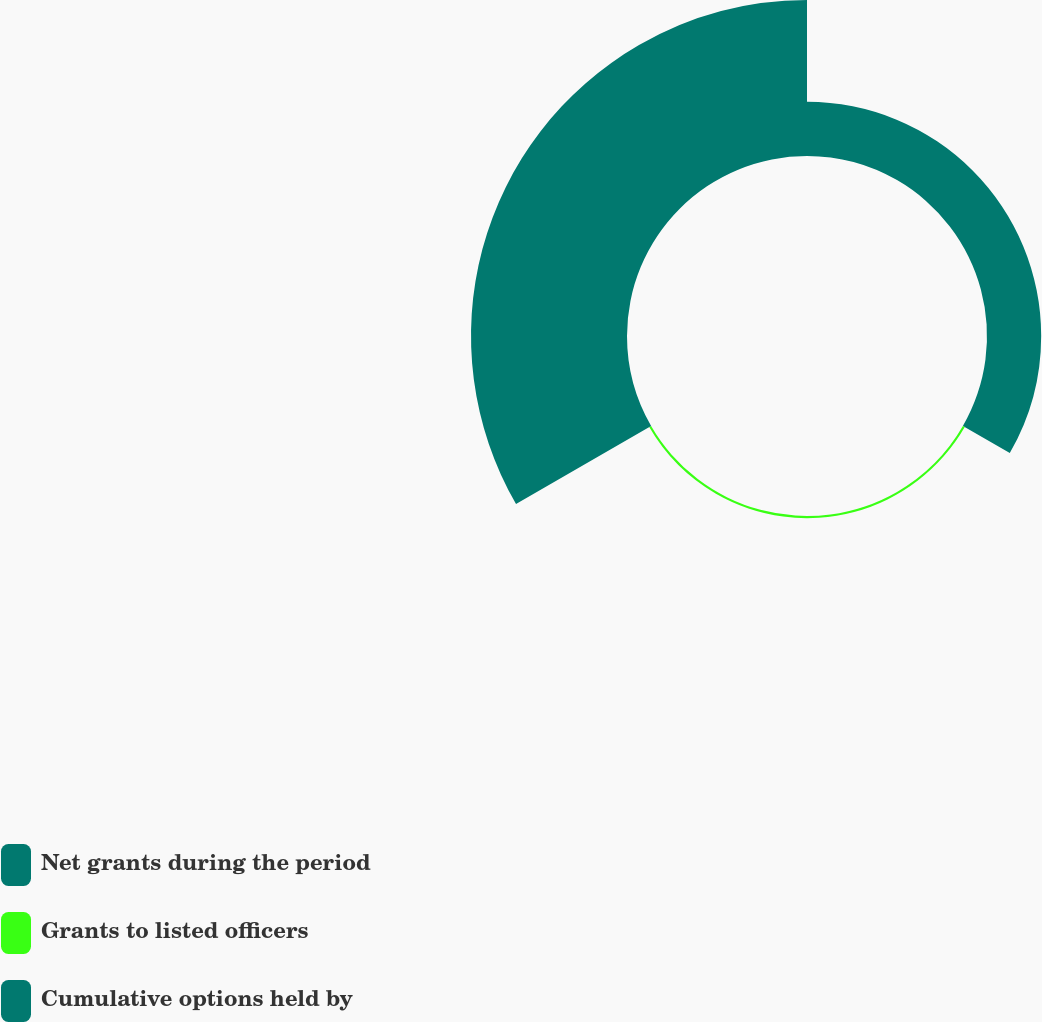Convert chart. <chart><loc_0><loc_0><loc_500><loc_500><pie_chart><fcel>Net grants during the period<fcel>Grants to listed officers<fcel>Cumulative options held by<nl><fcel>25.51%<fcel>1.02%<fcel>73.47%<nl></chart> 